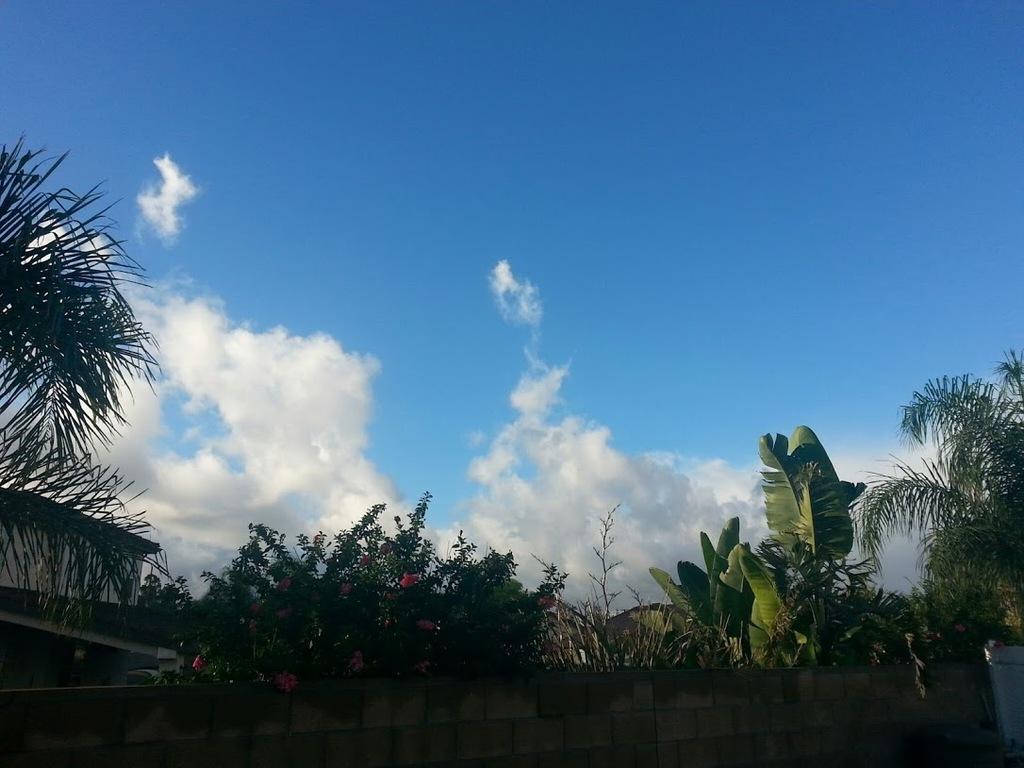Please provide a concise description of this image. This picture shows a building and few trees and a blue cloudy sky. 